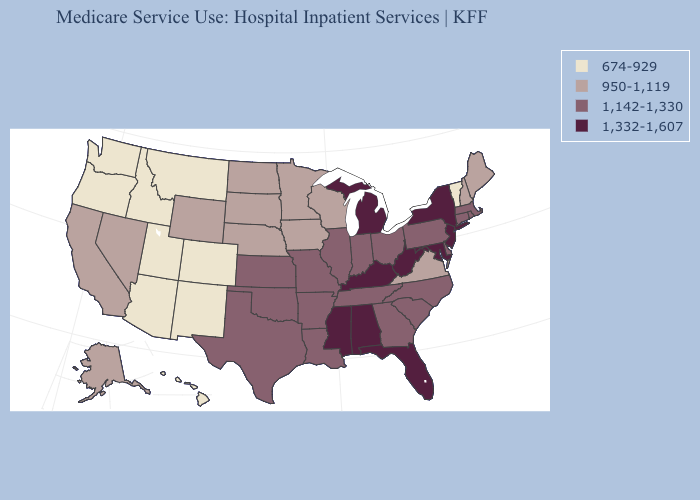What is the value of Oregon?
Quick response, please. 674-929. What is the value of Indiana?
Write a very short answer. 1,142-1,330. Which states have the highest value in the USA?
Keep it brief. Alabama, Florida, Kentucky, Maryland, Michigan, Mississippi, New Jersey, New York, West Virginia. Does Kentucky have the highest value in the USA?
Quick response, please. Yes. Does Massachusetts have the same value as Florida?
Short answer required. No. What is the highest value in the USA?
Short answer required. 1,332-1,607. Name the states that have a value in the range 674-929?
Short answer required. Arizona, Colorado, Hawaii, Idaho, Montana, New Mexico, Oregon, Utah, Vermont, Washington. Among the states that border Illinois , which have the lowest value?
Concise answer only. Iowa, Wisconsin. Does Idaho have a higher value than Maryland?
Keep it brief. No. What is the highest value in states that border Mississippi?
Give a very brief answer. 1,332-1,607. What is the lowest value in the USA?
Give a very brief answer. 674-929. Which states have the highest value in the USA?
Give a very brief answer. Alabama, Florida, Kentucky, Maryland, Michigan, Mississippi, New Jersey, New York, West Virginia. Name the states that have a value in the range 1,142-1,330?
Keep it brief. Arkansas, Connecticut, Delaware, Georgia, Illinois, Indiana, Kansas, Louisiana, Massachusetts, Missouri, North Carolina, Ohio, Oklahoma, Pennsylvania, Rhode Island, South Carolina, Tennessee, Texas. Does Vermont have the lowest value in the USA?
Keep it brief. Yes. What is the lowest value in the USA?
Be succinct. 674-929. 